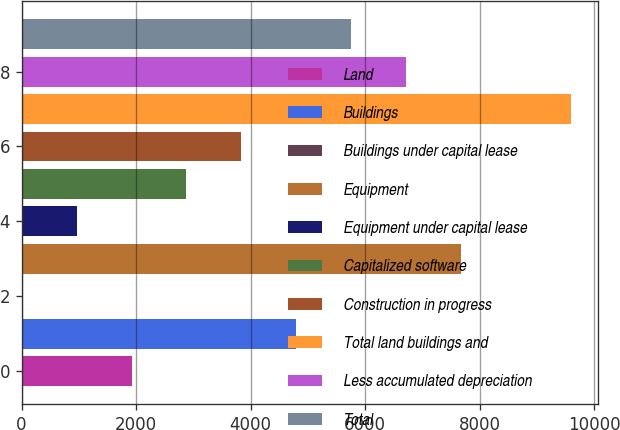Convert chart. <chart><loc_0><loc_0><loc_500><loc_500><bar_chart><fcel>Land<fcel>Buildings<fcel>Buildings under capital lease<fcel>Equipment<fcel>Equipment under capital lease<fcel>Capitalized software<fcel>Construction in progress<fcel>Total land buildings and<fcel>Less accumulated depreciation<fcel>Total<nl><fcel>1918.46<fcel>4795.7<fcel>0.3<fcel>7672.94<fcel>959.38<fcel>2877.54<fcel>3836.62<fcel>9591.1<fcel>6713.86<fcel>5754.78<nl></chart> 